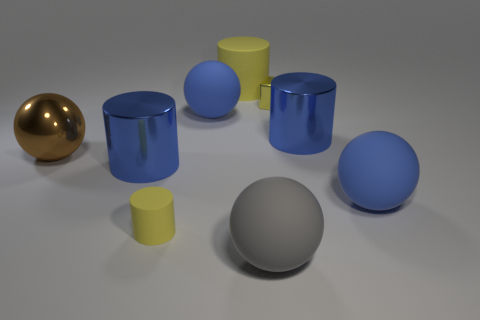Is there any other thing of the same color as the tiny cylinder?
Give a very brief answer. Yes. How many rubber things are either small green cylinders or small cubes?
Your response must be concise. 0. Is the big matte cylinder the same color as the small cylinder?
Make the answer very short. Yes. Are there more matte balls that are to the right of the yellow shiny thing than cyan spheres?
Give a very brief answer. Yes. How many other objects are there of the same material as the gray sphere?
Your answer should be compact. 4. How many tiny objects are gray things or matte spheres?
Offer a very short reply. 0. Does the gray object have the same material as the tiny cube?
Offer a very short reply. No. There is a blue cylinder that is behind the large brown metal sphere; how many blue metal things are to the left of it?
Provide a short and direct response. 1. Are there any large metal things that have the same shape as the large yellow matte thing?
Your answer should be very brief. Yes. Do the big blue rubber thing that is in front of the brown thing and the tiny yellow object in front of the brown metallic thing have the same shape?
Your answer should be compact. No. 